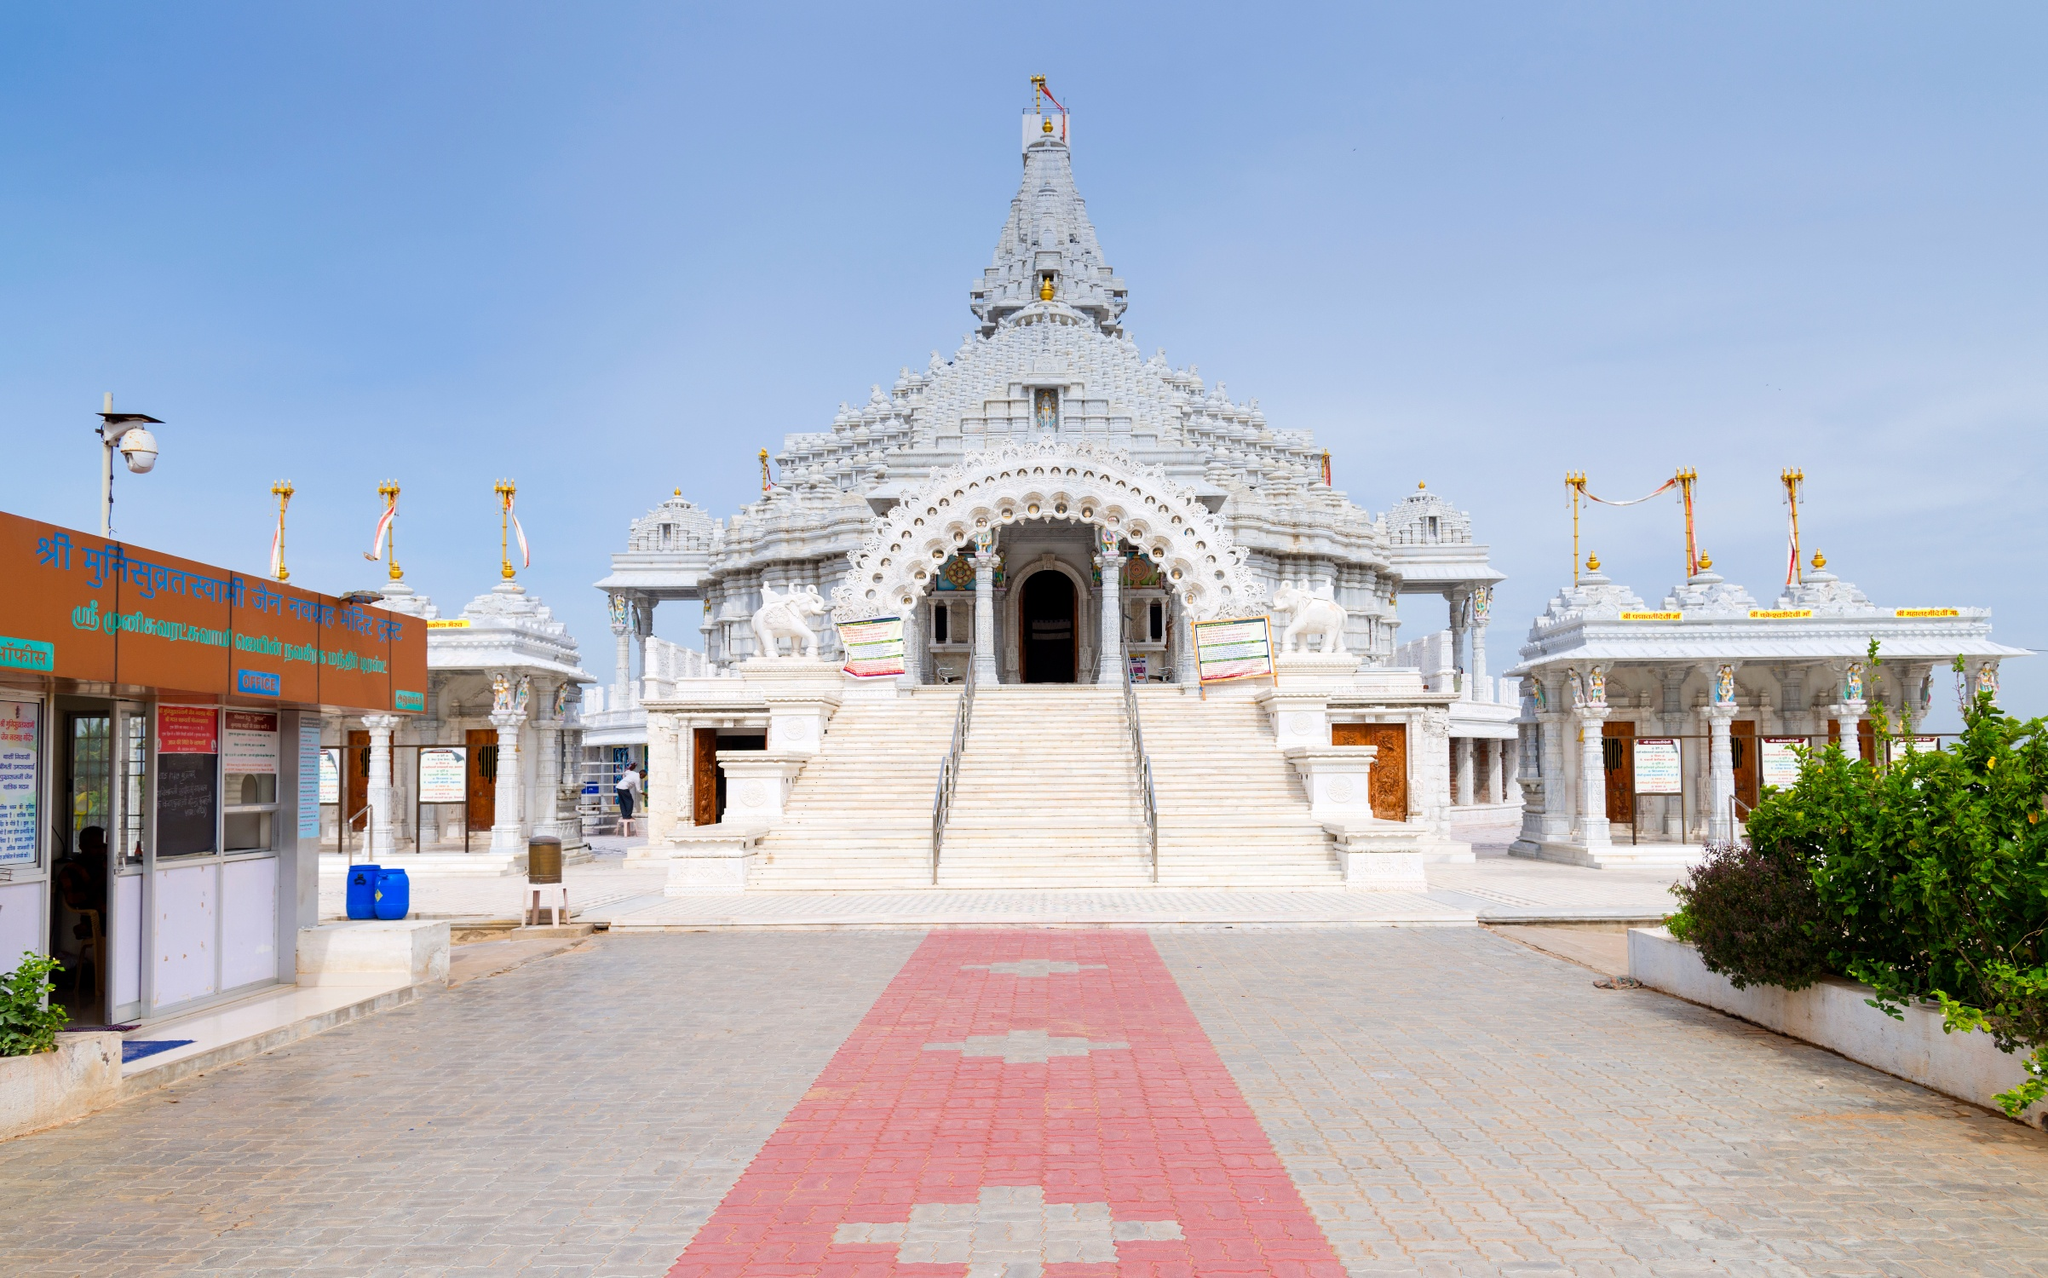Can you tell me more about the architectural style of this temple? Certainly! This temple appears to be designed in a style that bears resemblance to Nagara architecture, commonly found in North India. This architectural style is recognized by its beehive-shaped shikhara, elaborate ornamentation with sculptures of deities, and the presence of multiple subsidiary shrines around the main temple structure. The use of white marble adds to its grandeur, and the raised platform, known as a jagati, is typical in grand temple designs, possibly intended to elevate the temple above its surroundings, both physically and symbolically. 